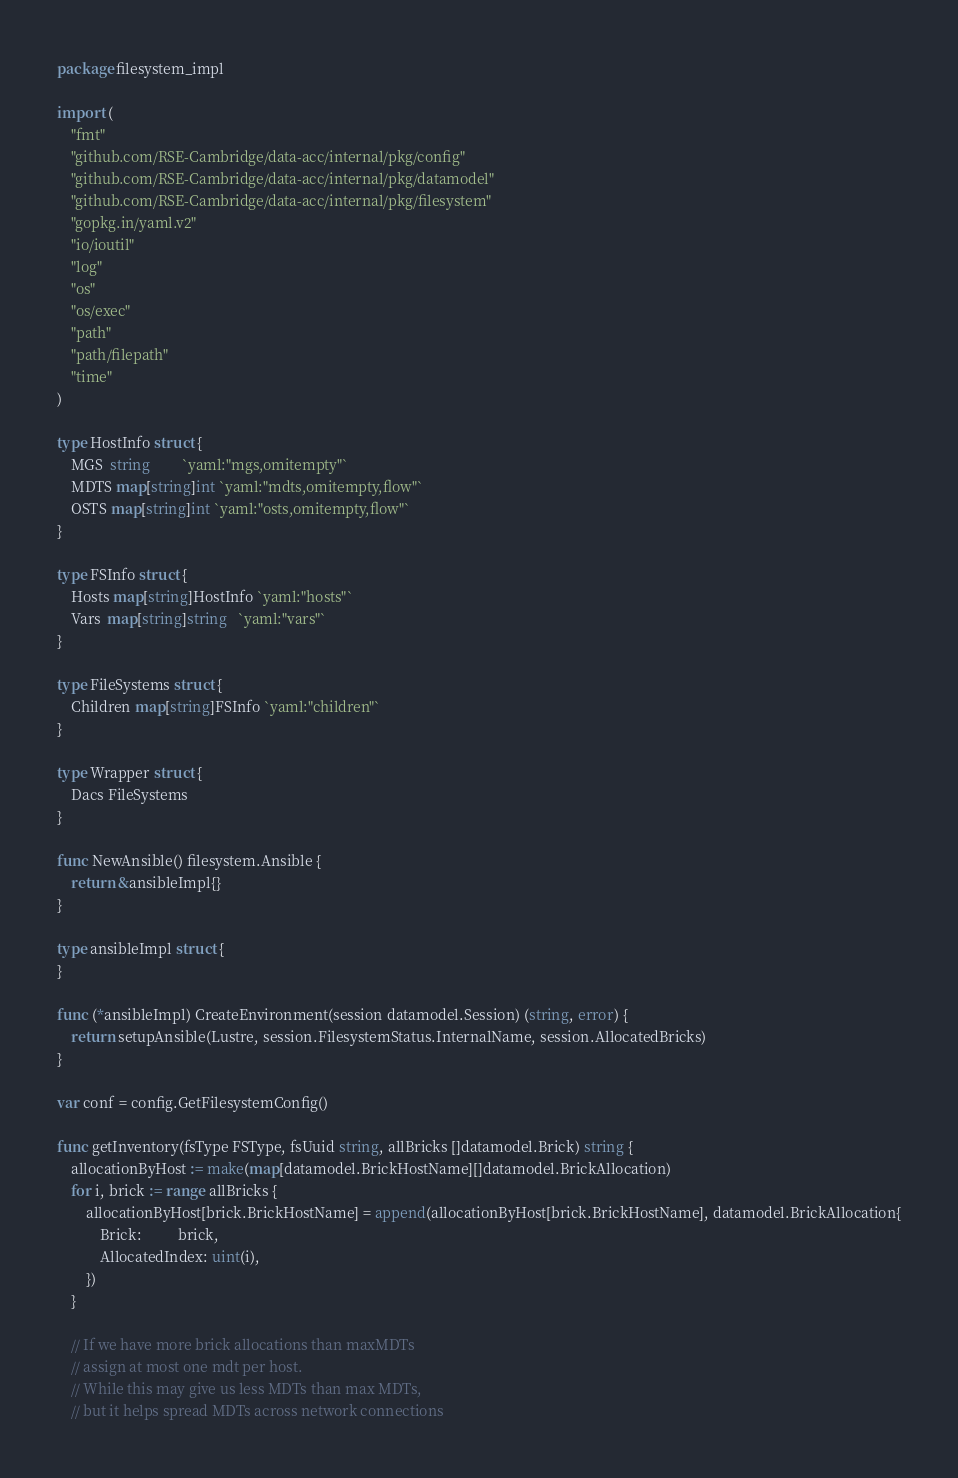Convert code to text. <code><loc_0><loc_0><loc_500><loc_500><_Go_>package filesystem_impl

import (
	"fmt"
	"github.com/RSE-Cambridge/data-acc/internal/pkg/config"
	"github.com/RSE-Cambridge/data-acc/internal/pkg/datamodel"
	"github.com/RSE-Cambridge/data-acc/internal/pkg/filesystem"
	"gopkg.in/yaml.v2"
	"io/ioutil"
	"log"
	"os"
	"os/exec"
	"path"
	"path/filepath"
	"time"
)

type HostInfo struct {
	MGS  string         `yaml:"mgs,omitempty"`
	MDTS map[string]int `yaml:"mdts,omitempty,flow"`
	OSTS map[string]int `yaml:"osts,omitempty,flow"`
}

type FSInfo struct {
	Hosts map[string]HostInfo `yaml:"hosts"`
	Vars  map[string]string   `yaml:"vars"`
}

type FileSystems struct {
	Children map[string]FSInfo `yaml:"children"`
}

type Wrapper struct {
	Dacs FileSystems
}

func NewAnsible() filesystem.Ansible {
	return &ansibleImpl{}
}

type ansibleImpl struct {
}

func (*ansibleImpl) CreateEnvironment(session datamodel.Session) (string, error) {
	return setupAnsible(Lustre, session.FilesystemStatus.InternalName, session.AllocatedBricks)
}

var conf = config.GetFilesystemConfig()

func getInventory(fsType FSType, fsUuid string, allBricks []datamodel.Brick) string {
	allocationByHost := make(map[datamodel.BrickHostName][]datamodel.BrickAllocation)
	for i, brick := range allBricks {
		allocationByHost[brick.BrickHostName] = append(allocationByHost[brick.BrickHostName], datamodel.BrickAllocation{
			Brick:          brick,
			AllocatedIndex: uint(i),
		})
	}

	// If we have more brick allocations than maxMDTs
	// assign at most one mdt per host.
	// While this may give us less MDTs than max MDTs,
	// but it helps spread MDTs across network connections</code> 